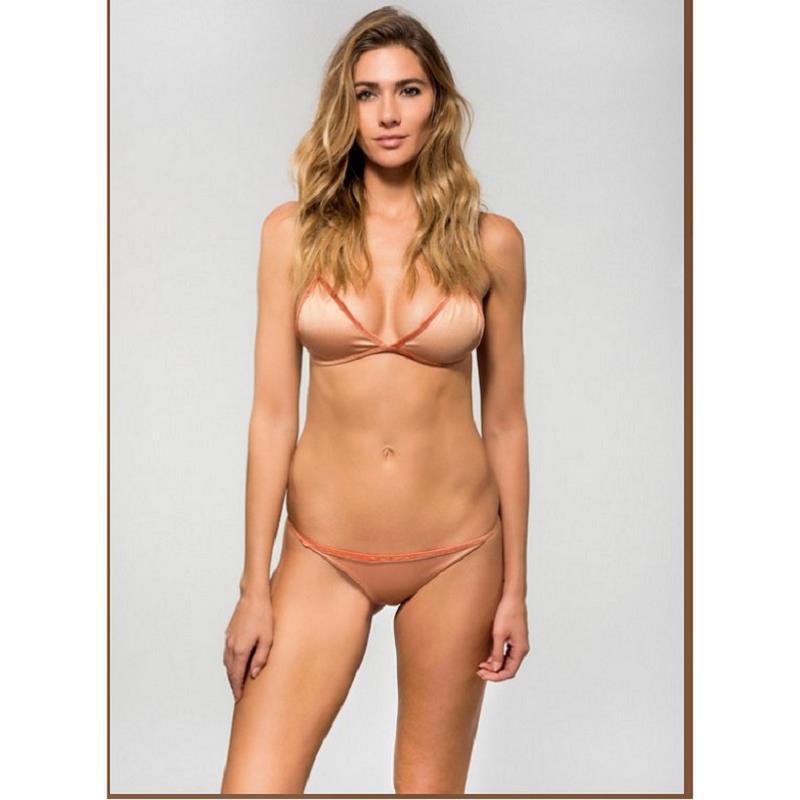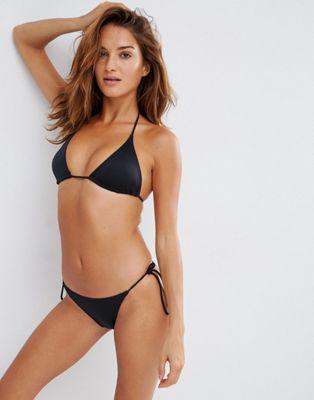The first image is the image on the left, the second image is the image on the right. Assess this claim about the two images: "A blonde model wears a light green bikini in one image.". Correct or not? Answer yes or no. No. The first image is the image on the left, the second image is the image on the right. For the images displayed, is the sentence "There is one green bikini" factually correct? Answer yes or no. No. 